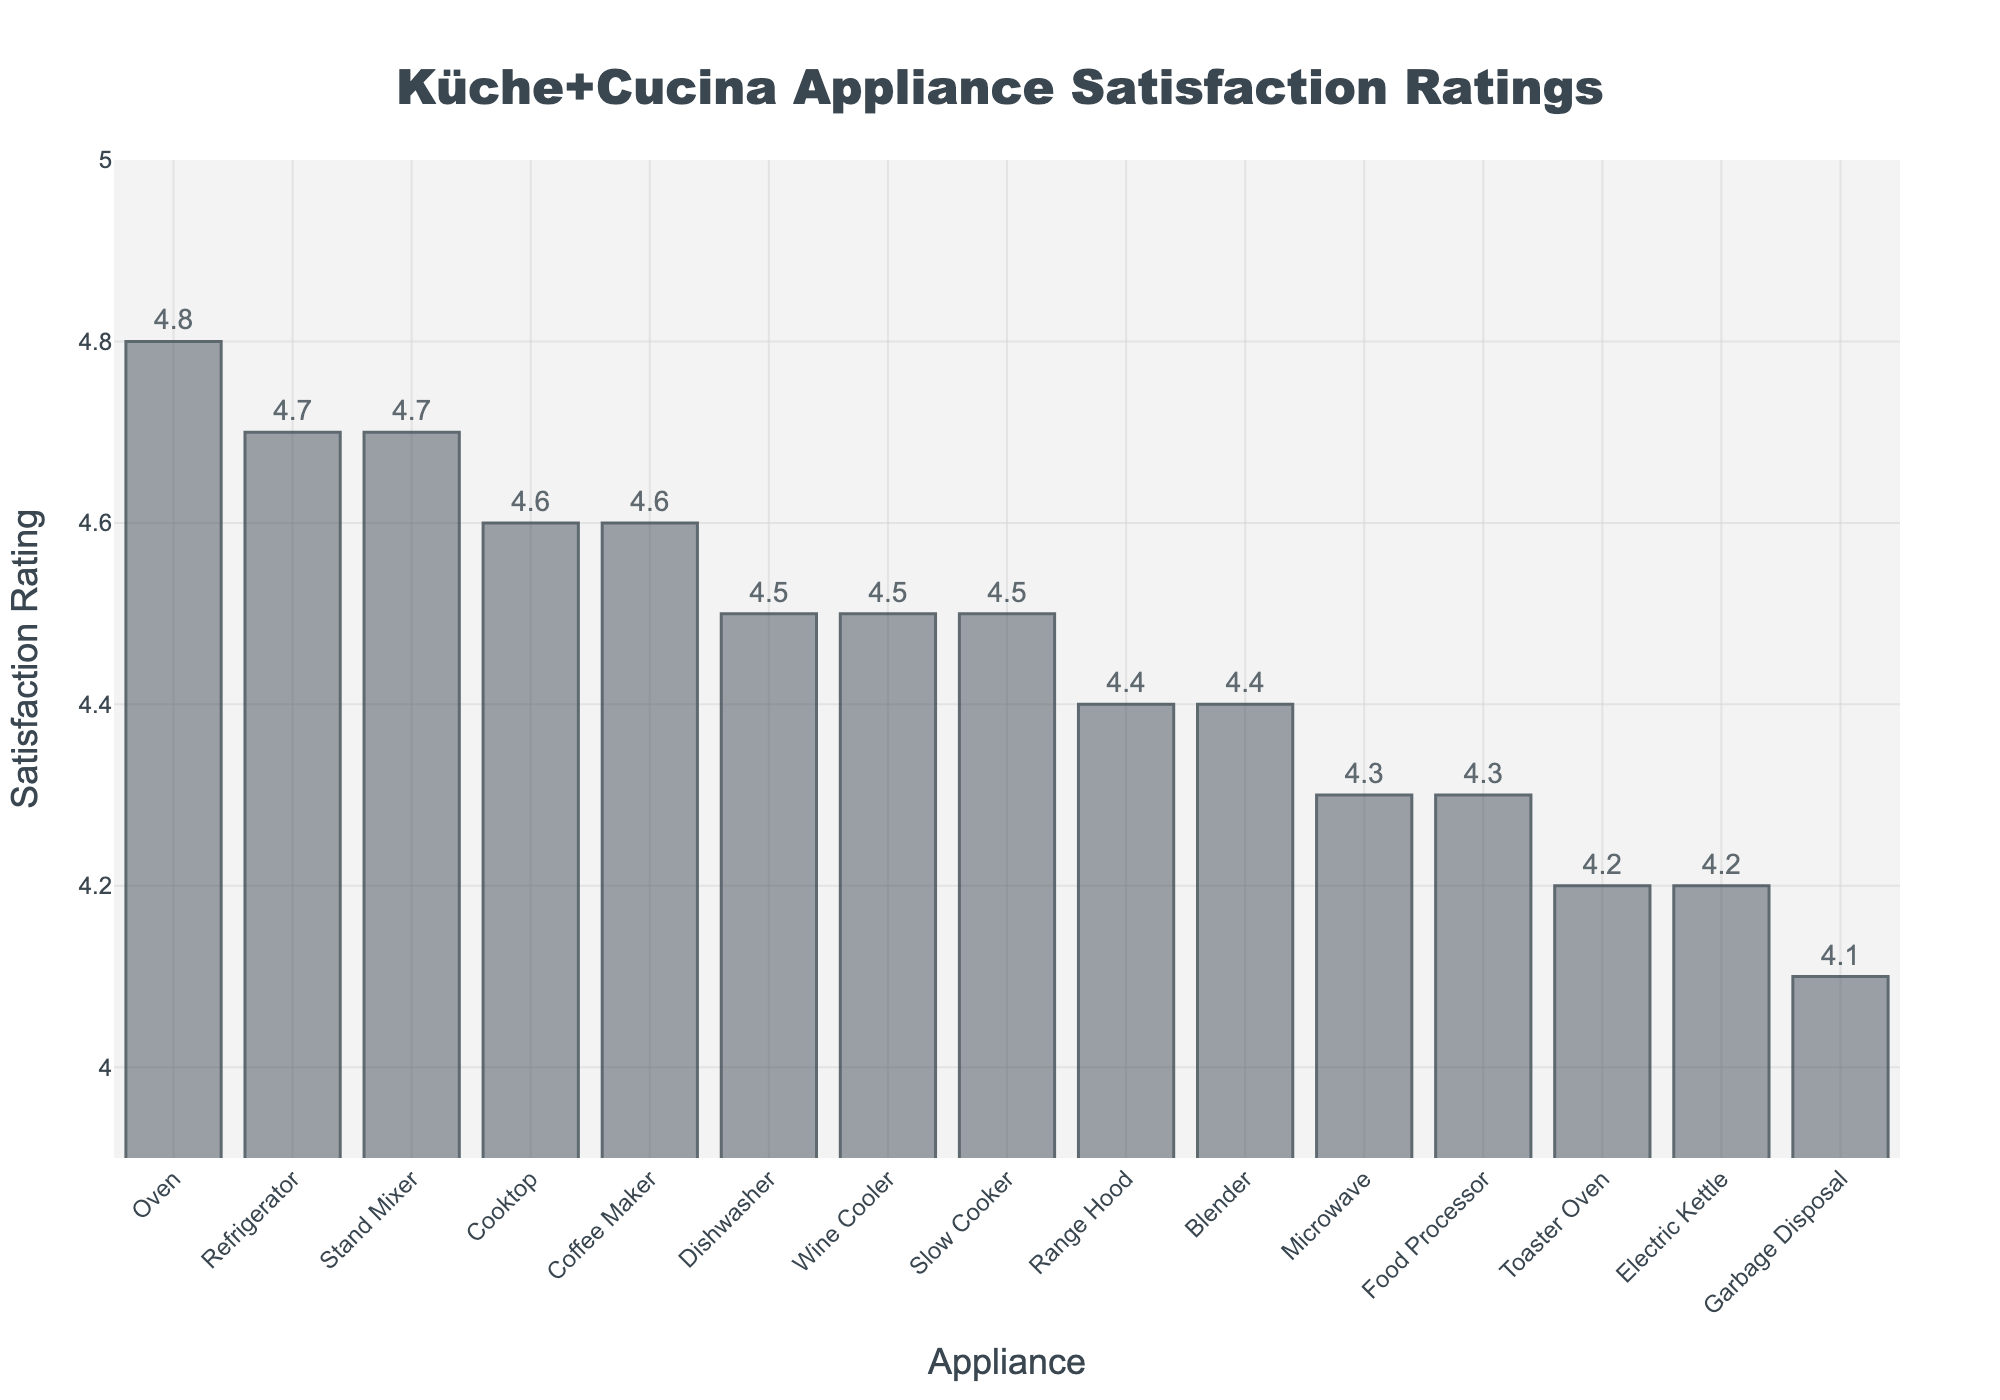What's the highest satisfaction rating among the appliances? Look at the bar chart and identify the tallest bar. The label on this bar will be the appliance with the highest satisfaction rating.
Answer: Oven What's the lowest satisfaction rating among the appliances? Look at the bar chart and identify the shortest bar. The label on this bar will be the appliance with the lowest satisfaction rating.
Answer: Garbage Disposal Which appliances have a satisfaction rating greater than 4.5? Identify the bars that reach above the 4.5 satisfaction rating mark on the y-axis. Look at the labels of these bars to list the appliances.
Answer: Refrigerator, Oven, Cooktop, Coffee Maker, Stand Mixer, Slow Cooker, Dishwasher, Wine Cooler How many appliances have a satisfaction rating of 4.2 or lower? Identify the bars that reach up to or below the 4.2 satisfaction rating mark on the y-axis. Count the number of these bars.
Answer: 3 What is the difference in satisfaction rating between the appliance with the highest and the lowest rating? Identify the highest and lowest satisfaction rating values from the chart, then subtract the lowest from the highest. 4.8 (highest) - 4.1 (lowest) = 0.7
Answer: 0.7 On average, how satisfied are customers with the appliances? Sum up all the satisfaction ratings and divide by the number of appliances. Adding all ratings: 4.7 + 4.5 + 4.8 + 4.6 + 4.3 + 4.4 + 4.6 + 4.2 + 4.5 + 4.1 + 4.4 + 4.3 + 4.7 + 4.2 + 4.5 = 66.8. Divide by 15 appliances: 66.8 / 15 = 4.45
Answer: 4.45 Are there more appliances with satisfaction ratings higher than 4.5 or lower than 4.5? Count the number of appliances with satisfaction ratings higher than 4.5 and those with ratings lower than or equal to 4.5. Compare the counts. Eight appliances have ratings higher than 4.5, while seven have ratings lower or equal to 4.5.
Answer: Higher than 4.5 Which appliances have the same satisfaction rating of 4.6? Identify all the bars that have a height corresponding to the satisfaction rating of 4.6. Check the labels for these bars.
Answer: Cooktop, Coffee Maker What is the combined satisfaction rating of Microwave and Toaster Oven? Identify the satisfaction ratings for both Microwave and Toaster Oven from the chart and then add them together. 4.3 (Microwave) + 4.2 (Toaster Oven) = 8.5
Answer: 8.5 Are there more appliances with a rating above 4.4 or equal to or below 4.4? Count the number of appliances with a satisfaction rating above 4.4 and those with a rating equal to or below 4.4. Compare the counts. Seven appliances have ratings above 4.4, while eight have ratings equal to or below 4.4.
Answer: Equal to or below 